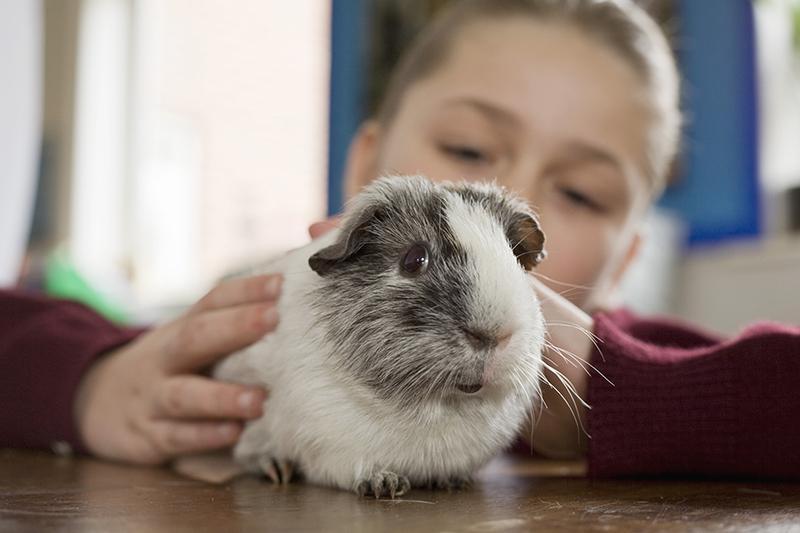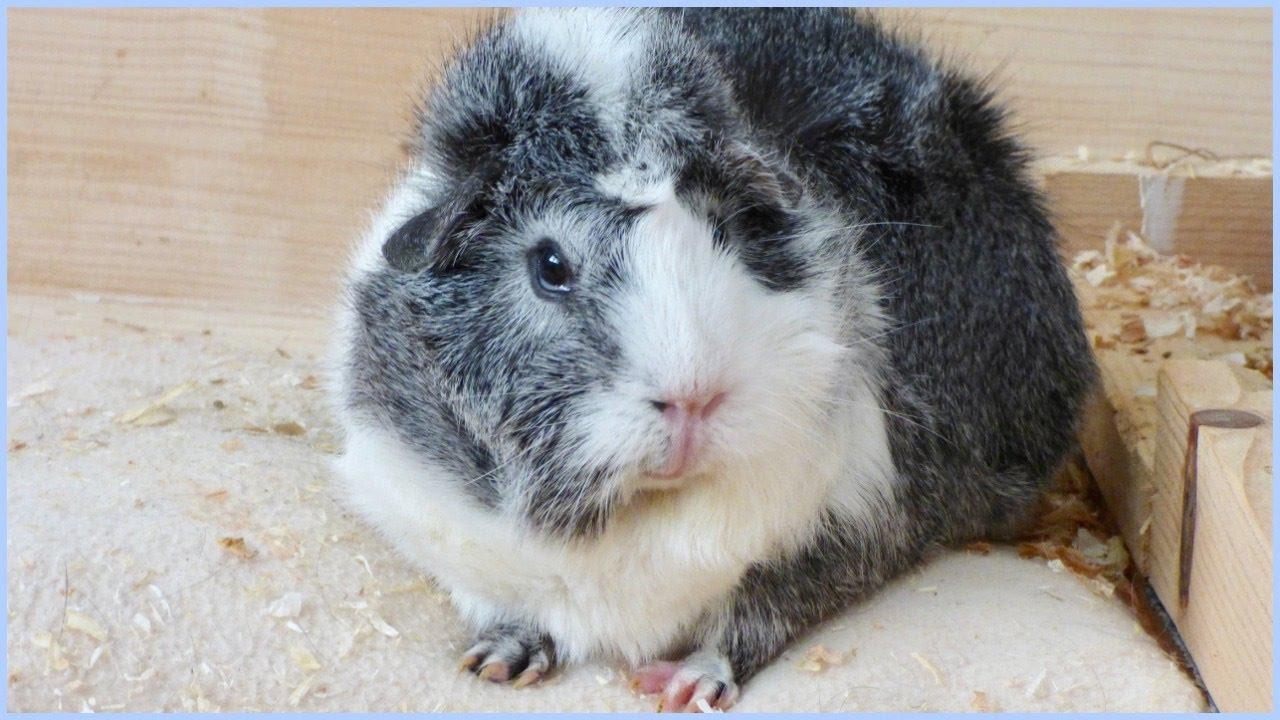The first image is the image on the left, the second image is the image on the right. Given the left and right images, does the statement "There are three hamsters in total." hold true? Answer yes or no. No. The first image is the image on the left, the second image is the image on the right. For the images displayed, is the sentence "In total, three guinea pigs are shown, and the right image contains more animals than the left image." factually correct? Answer yes or no. No. 